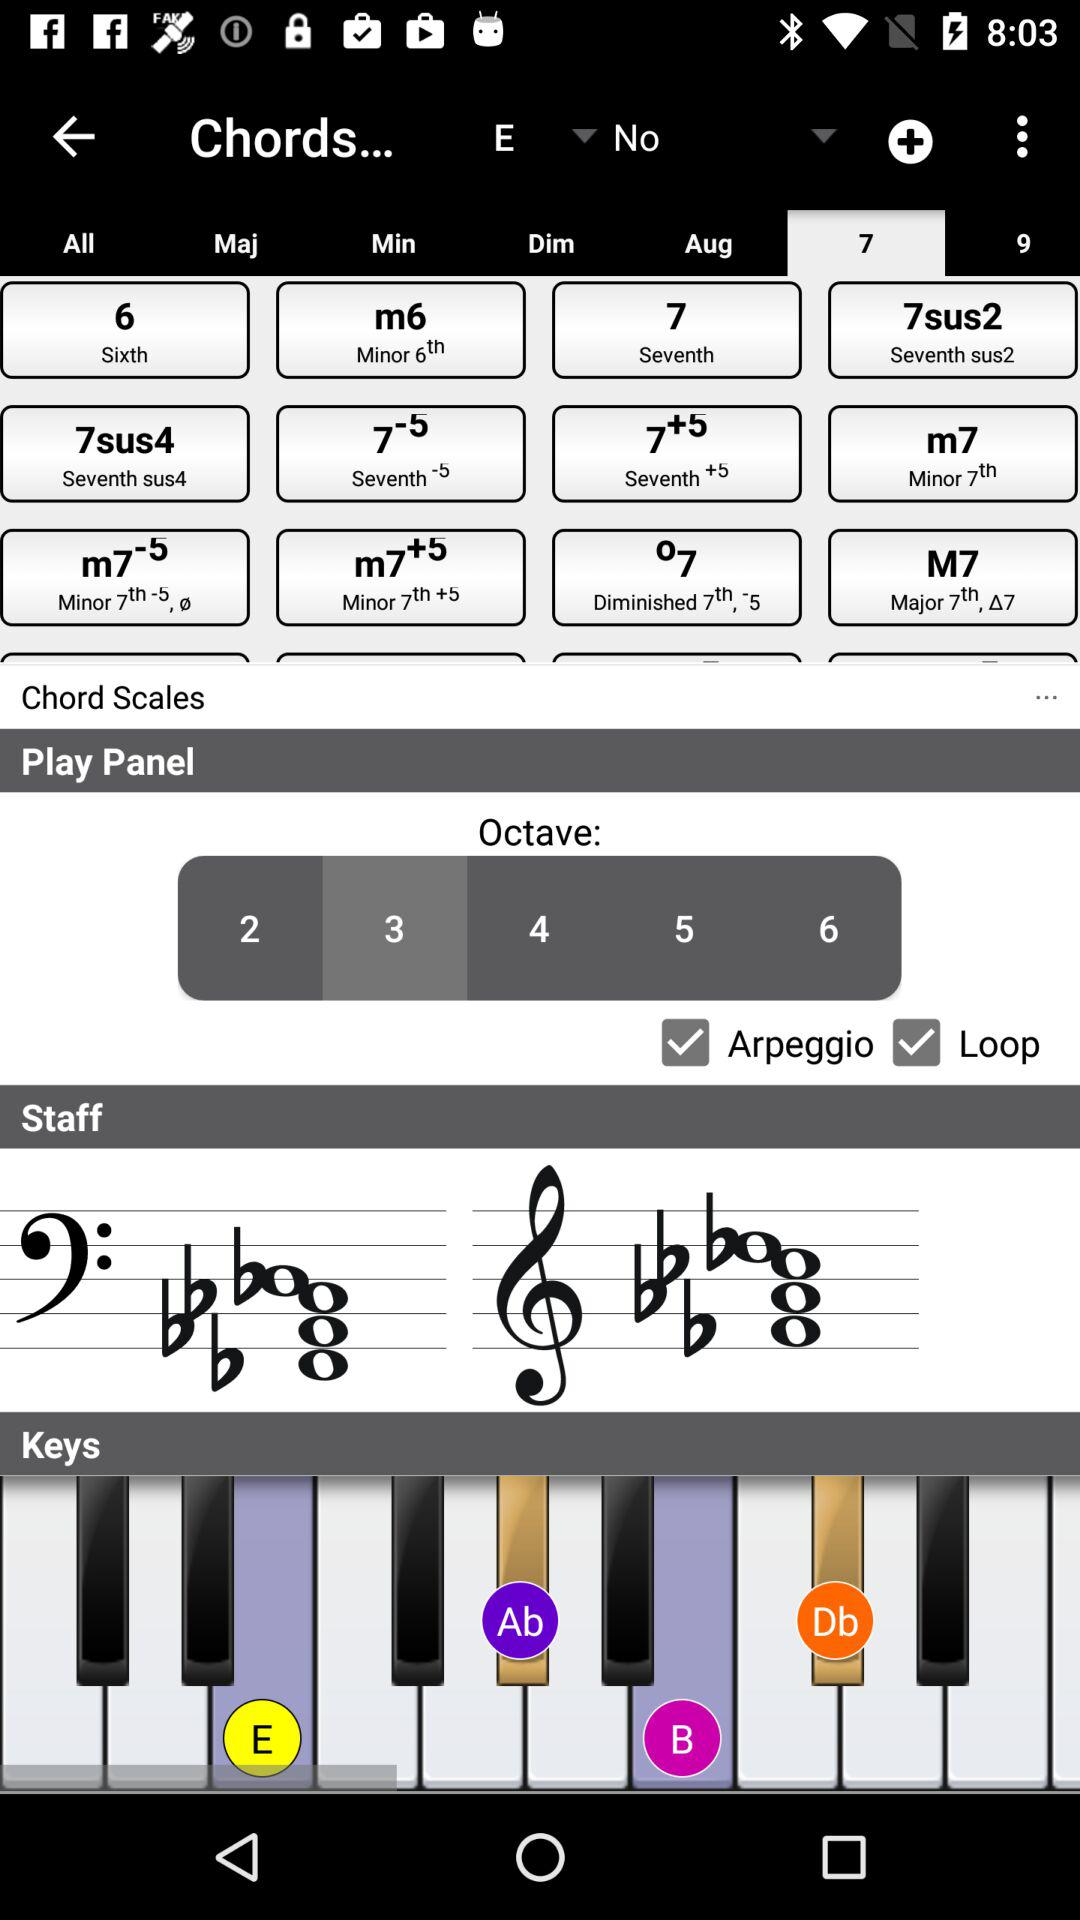What is the selected octave? The selected octave is 3. 